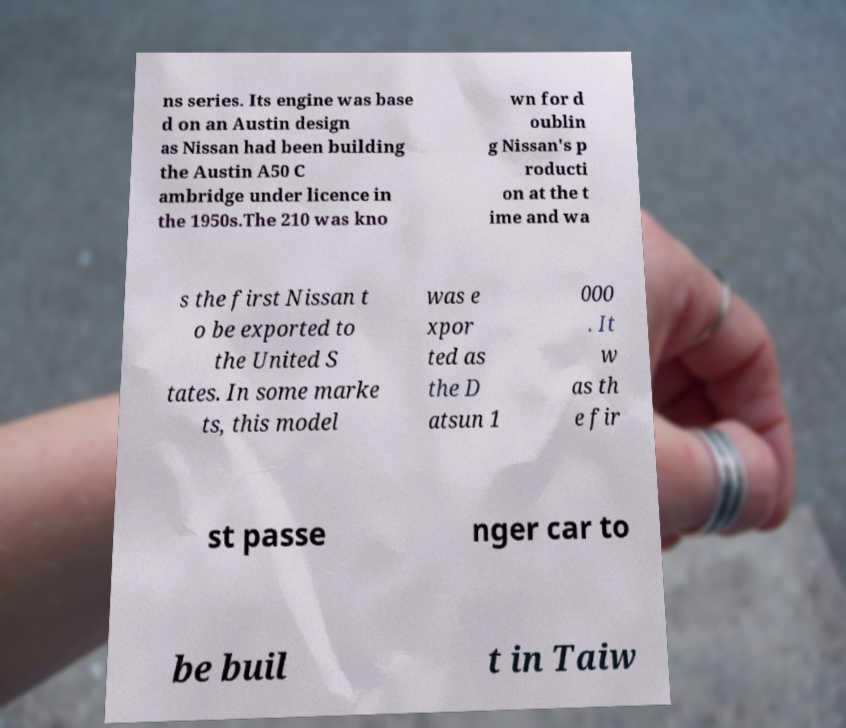Please read and relay the text visible in this image. What does it say? ns series. Its engine was base d on an Austin design as Nissan had been building the Austin A50 C ambridge under licence in the 1950s.The 210 was kno wn for d oublin g Nissan's p roducti on at the t ime and wa s the first Nissan t o be exported to the United S tates. In some marke ts, this model was e xpor ted as the D atsun 1 000 . It w as th e fir st passe nger car to be buil t in Taiw 